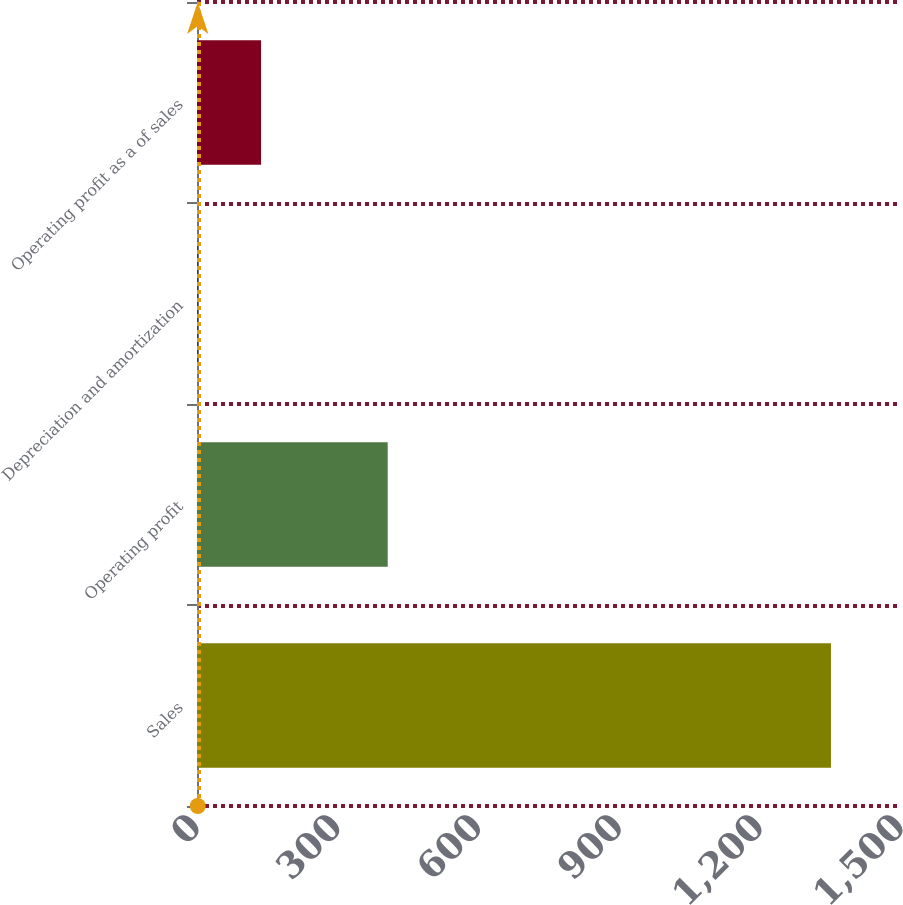Convert chart to OTSL. <chart><loc_0><loc_0><loc_500><loc_500><bar_chart><fcel>Sales<fcel>Operating profit<fcel>Depreciation and amortization<fcel>Operating profit as a of sales<nl><fcel>1350.8<fcel>406.36<fcel>1.6<fcel>136.52<nl></chart> 